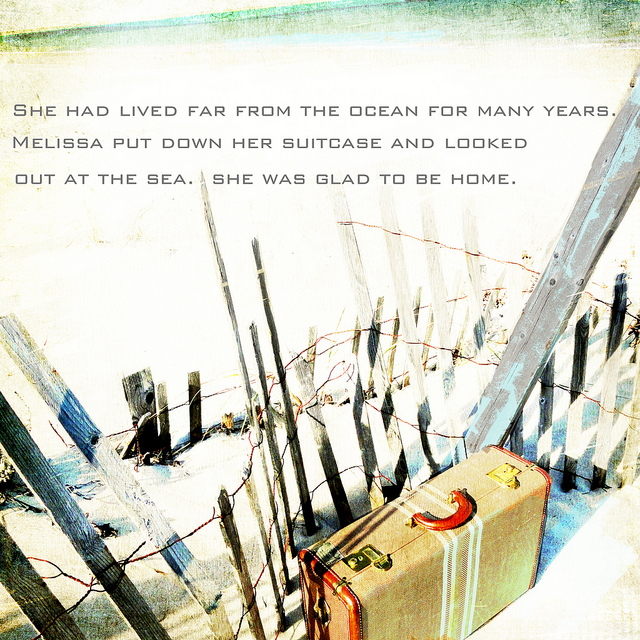Extract all visible text content from this image. SHE HAD LIVED FAR PUT HOME BE TO GLAD WAS SHE SEA THE AT OUT LOOKED AND SUITCASE HER DOWN MELISSA YEARS MANY FOR OCEAN THE FROM 